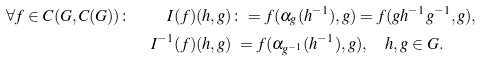<formula> <loc_0><loc_0><loc_500><loc_500>\forall f \in C ( G , C ( G ) ) \colon \quad I ( f ) ( h , g ) & \colon = f ( \alpha _ { g } ( h ^ { - 1 } ) , g ) = f ( g h ^ { - 1 } g ^ { - 1 } , g ) , \\ I ^ { - 1 } ( f ) ( h , g ) & \ = f ( \alpha _ { g ^ { - 1 } } ( h ^ { - 1 } ) , g ) , \quad h , g \in G .</formula> 